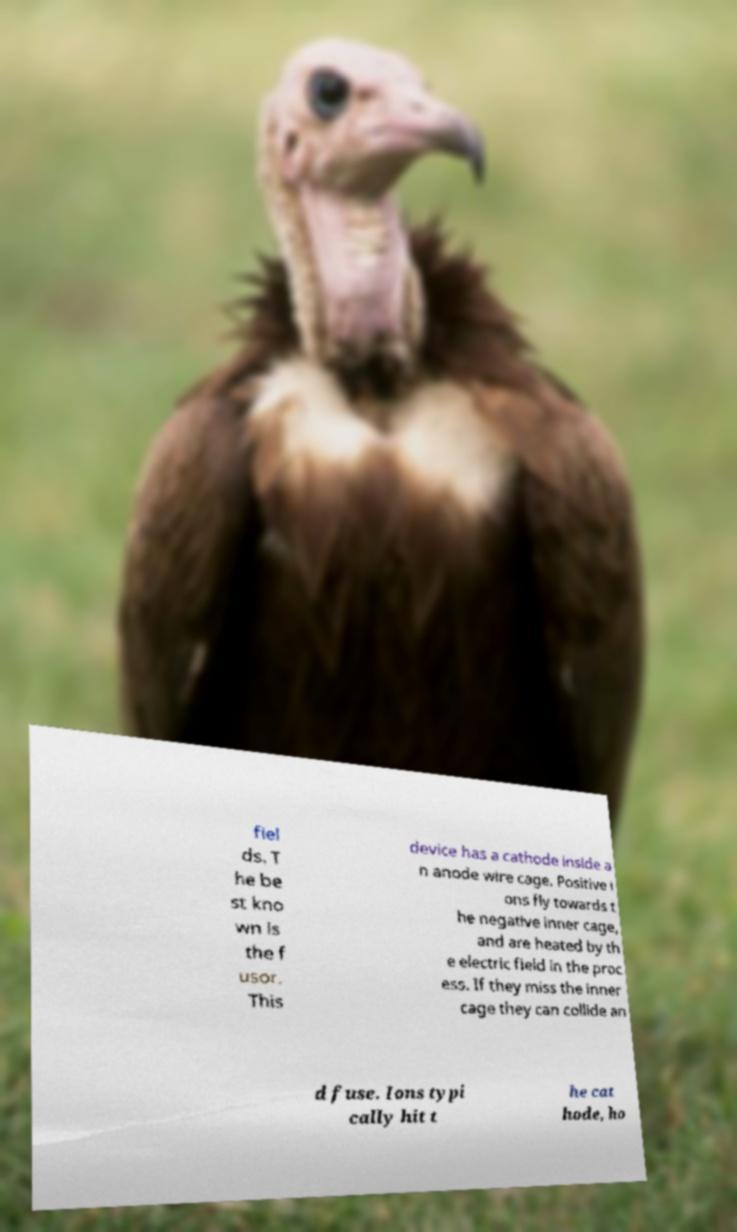I need the written content from this picture converted into text. Can you do that? fiel ds. T he be st kno wn is the f usor. This device has a cathode inside a n anode wire cage. Positive i ons fly towards t he negative inner cage, and are heated by th e electric field in the proc ess. If they miss the inner cage they can collide an d fuse. Ions typi cally hit t he cat hode, ho 